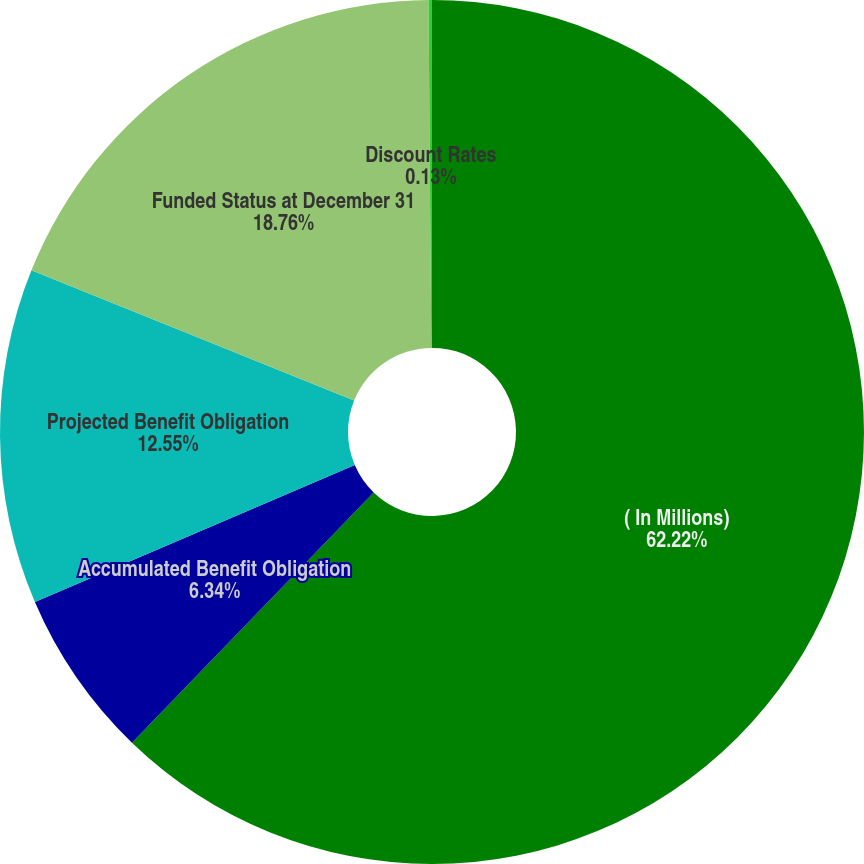Convert chart to OTSL. <chart><loc_0><loc_0><loc_500><loc_500><pie_chart><fcel>( In Millions)<fcel>Accumulated Benefit Obligation<fcel>Projected Benefit Obligation<fcel>Funded Status at December 31<fcel>Discount Rates<nl><fcel>62.22%<fcel>6.34%<fcel>12.55%<fcel>18.76%<fcel>0.13%<nl></chart> 